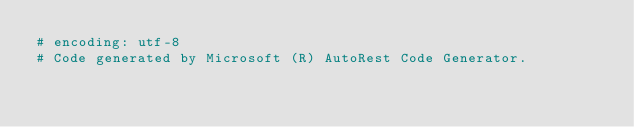<code> <loc_0><loc_0><loc_500><loc_500><_Ruby_># encoding: utf-8
# Code generated by Microsoft (R) AutoRest Code Generator.</code> 